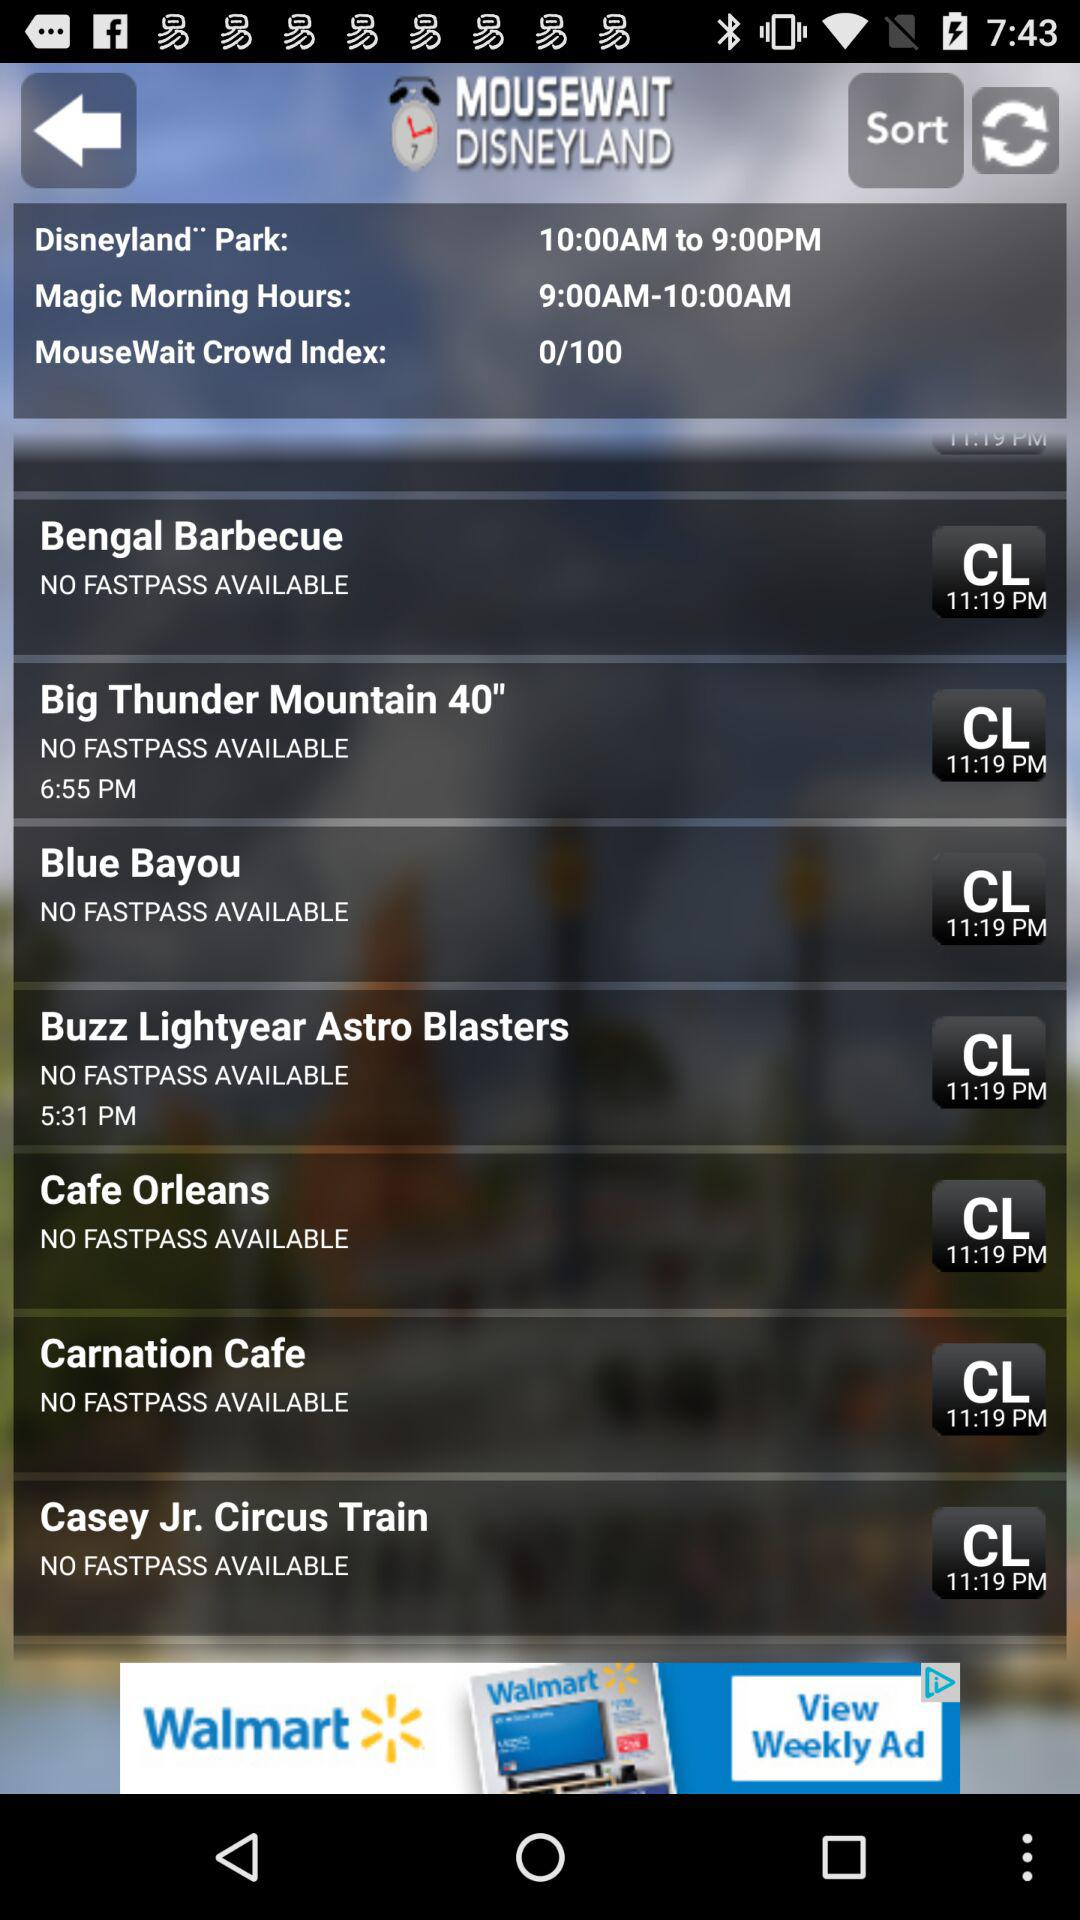What's the scheduled time of the "Magic Morning Hours"? The scheduled time of the "Magic Morning Hours" is from 9:00 AM to 10:00 AM. 